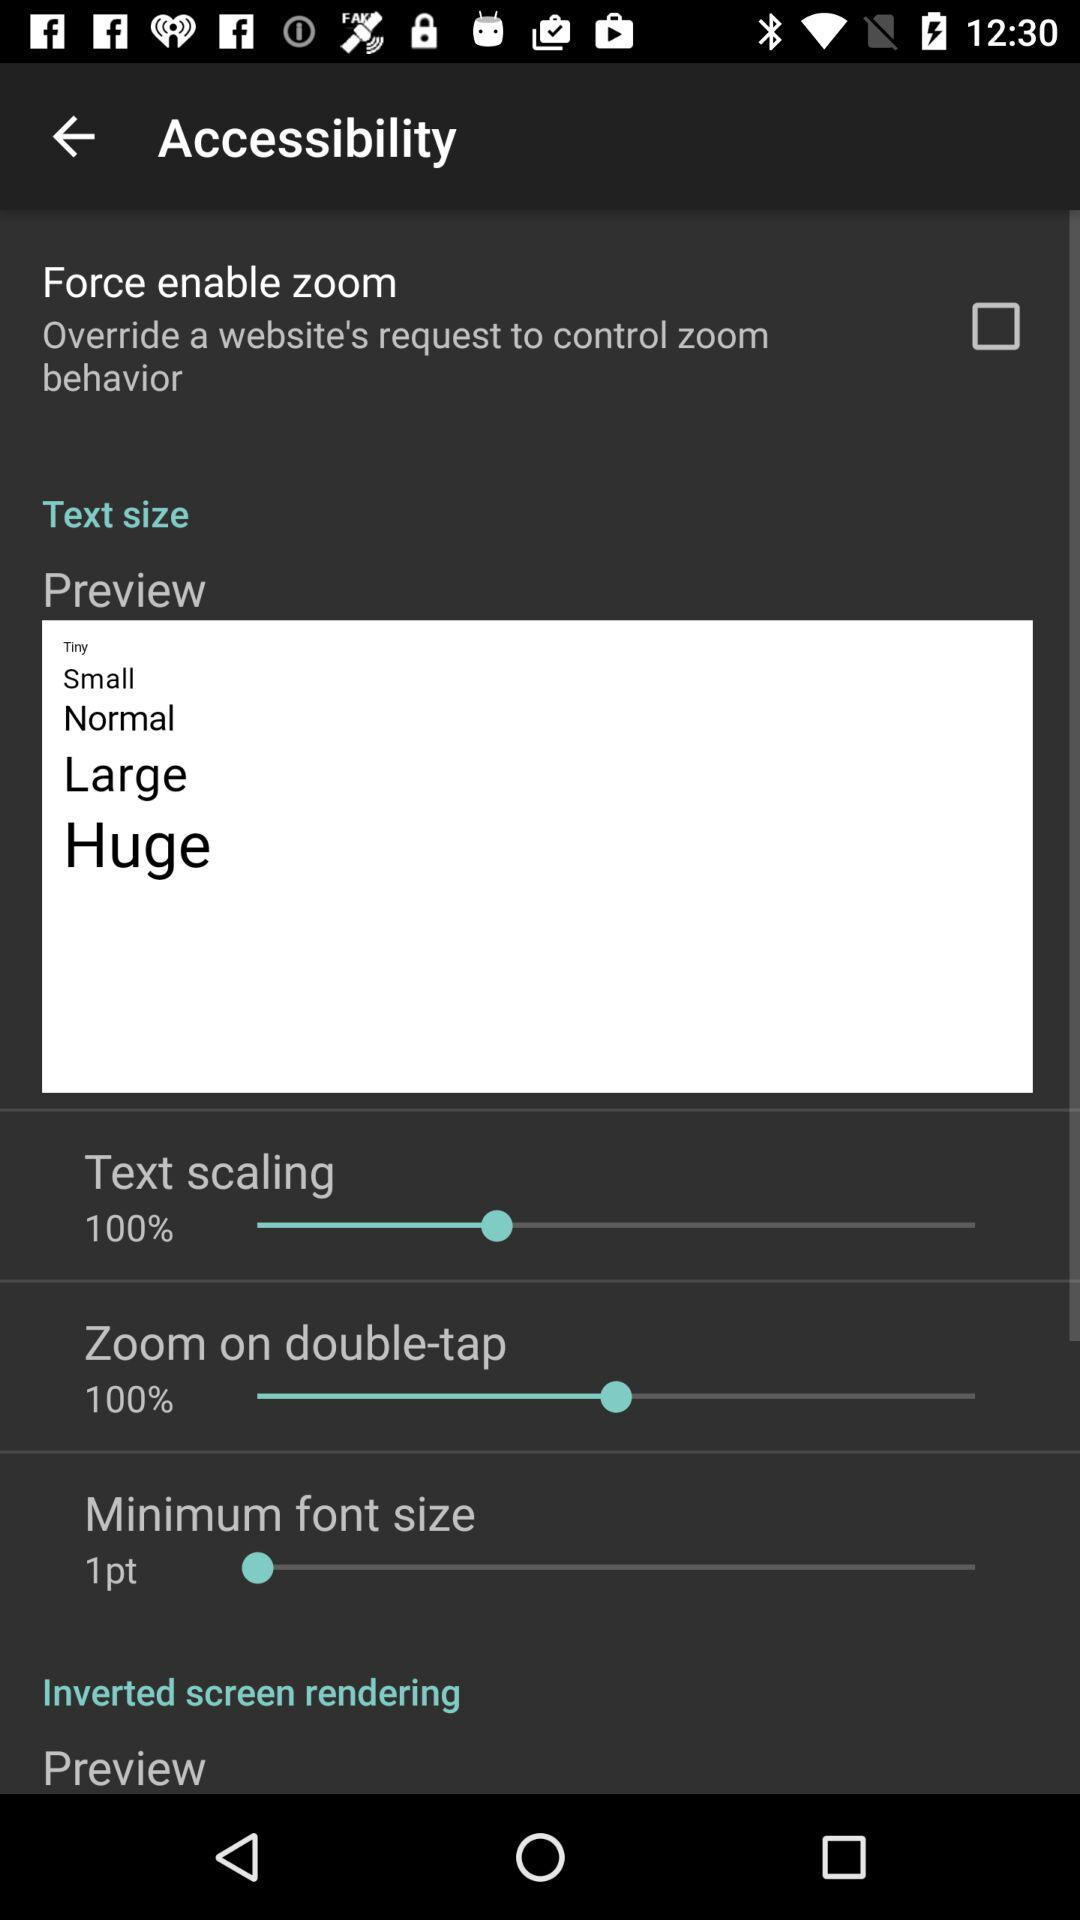What is the text scaling percentage? The text scaling percentage is 100. 